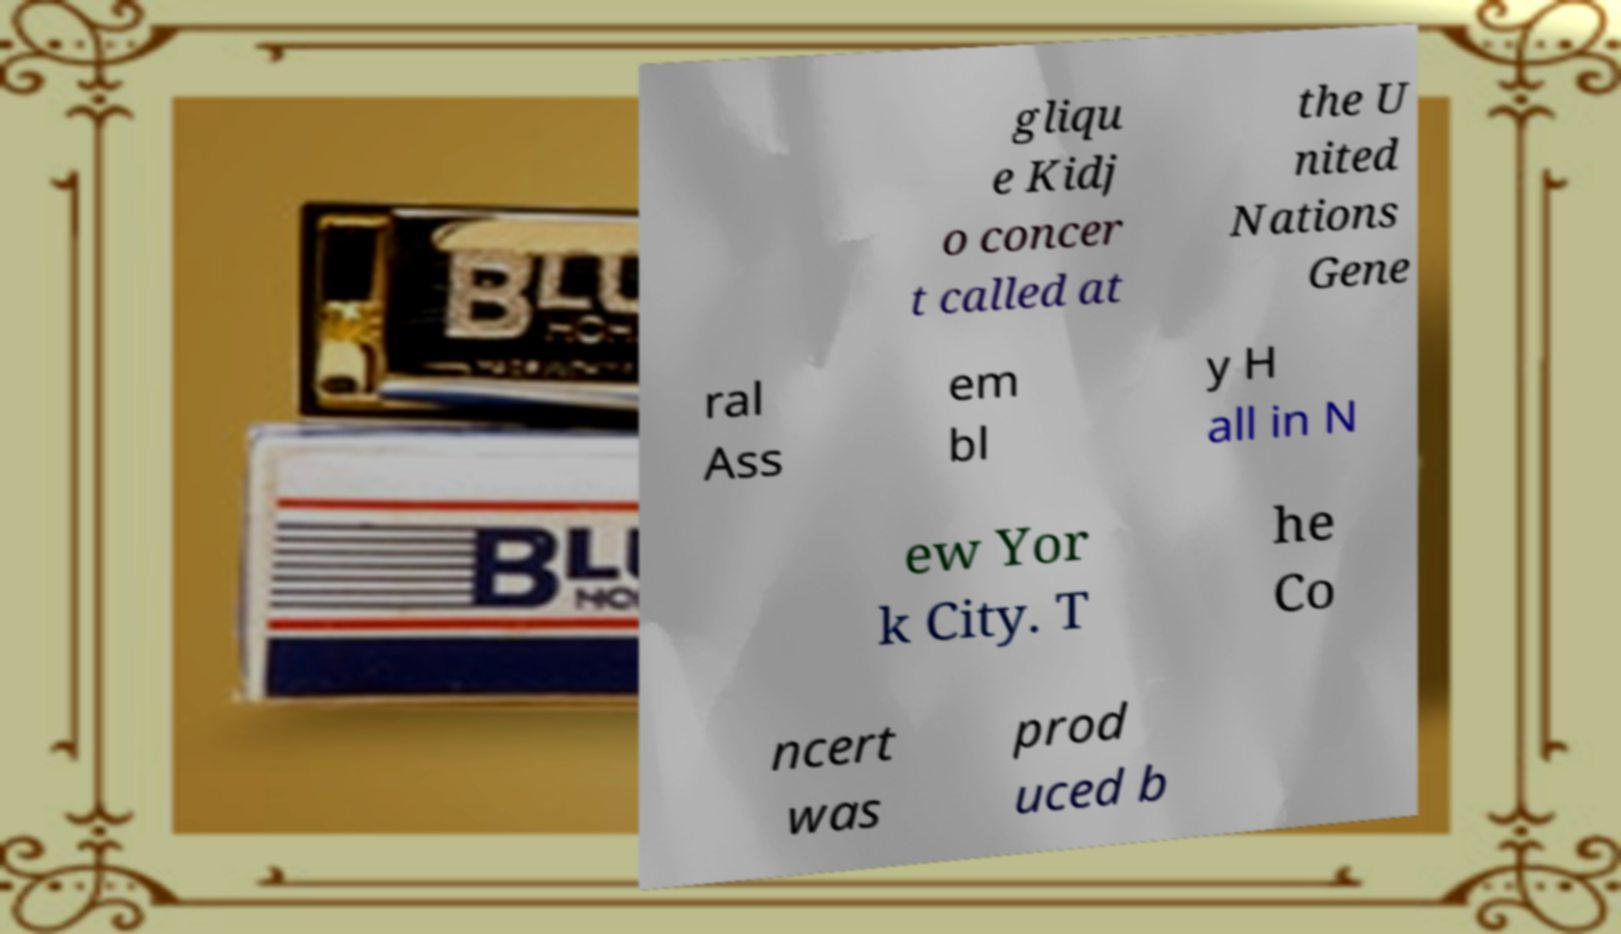Please identify and transcribe the text found in this image. gliqu e Kidj o concer t called at the U nited Nations Gene ral Ass em bl y H all in N ew Yor k City. T he Co ncert was prod uced b 